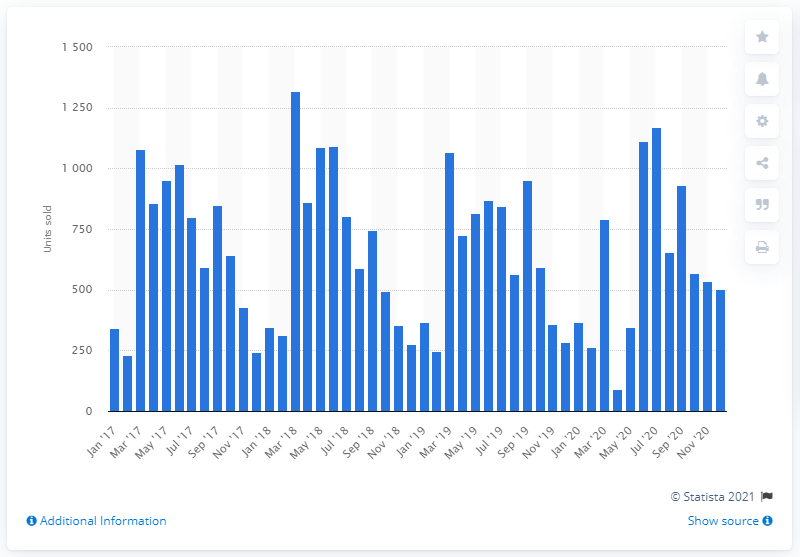Draw attention to some important aspects in this diagram. In April 2020, a total of 91 custom motorcycles were sold. 